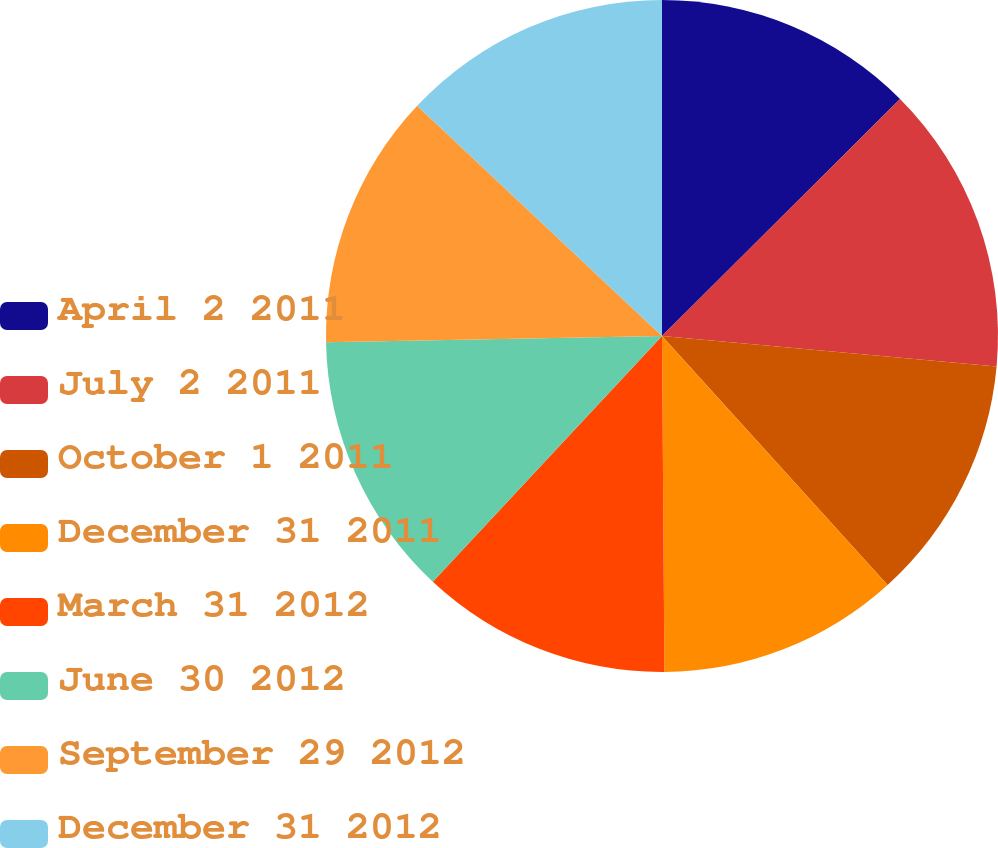Convert chart. <chart><loc_0><loc_0><loc_500><loc_500><pie_chart><fcel>April 2 2011<fcel>July 2 2011<fcel>October 1 2011<fcel>December 31 2011<fcel>March 31 2012<fcel>June 30 2012<fcel>September 29 2012<fcel>December 31 2012<nl><fcel>12.53%<fcel>13.92%<fcel>11.83%<fcel>11.6%<fcel>12.06%<fcel>12.76%<fcel>12.3%<fcel>12.99%<nl></chart> 